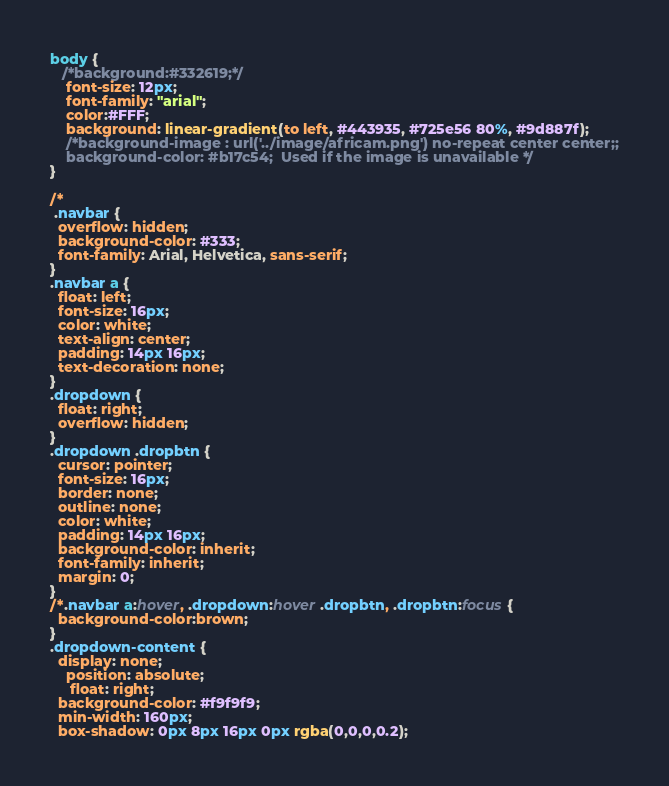Convert code to text. <code><loc_0><loc_0><loc_500><loc_500><_CSS_>body { 
   /*background:#332619;*/ 
	font-size: 12px;
	font-family: "arial";
   	color:#FFF; 
	background: linear-gradient(to left, #443935, #725e56 80%, #9d887f);
	/*background-image : url('../image/africam.png') no-repeat center center;;
	background-color: #b17c54;  Used if the image is unavailable */
}

/*
 .navbar {
  overflow: hidden;
  background-color: #333;
  font-family: Arial, Helvetica, sans-serif;
}
.navbar a {
  float: left;
  font-size: 16px;
  color: white;
  text-align: center;
  padding: 14px 16px;
  text-decoration: none;
}
.dropdown {
  float: right;
  overflow: hidden;
}
.dropdown .dropbtn {
  cursor: pointer;
  font-size: 16px;  
  border: none;
  outline: none;
  color: white;
  padding: 14px 16px;
  background-color: inherit;
  font-family: inherit;
  margin: 0;
}
/*.navbar a:hover, .dropdown:hover .dropbtn, .dropbtn:focus {
  background-color:brown;
}
.dropdown-content {
  display: none;
	position: absolute;
	 float: right;
  background-color: #f9f9f9;
  min-width: 160px;
  box-shadow: 0px 8px 16px 0px rgba(0,0,0,0.2);</code> 